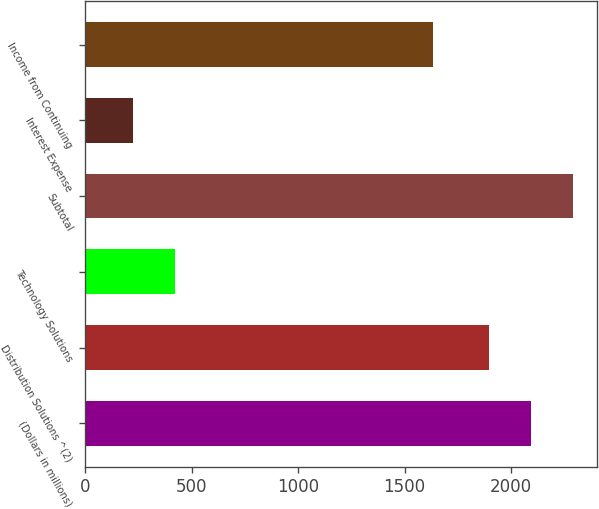Convert chart. <chart><loc_0><loc_0><loc_500><loc_500><bar_chart><fcel>(Dollars in millions)<fcel>Distribution Solutions ^(2)<fcel>Technology Solutions<fcel>Subtotal<fcel>Interest Expense<fcel>Income from Continuing<nl><fcel>2094.6<fcel>1897<fcel>419.6<fcel>2292.2<fcel>222<fcel>1635<nl></chart> 